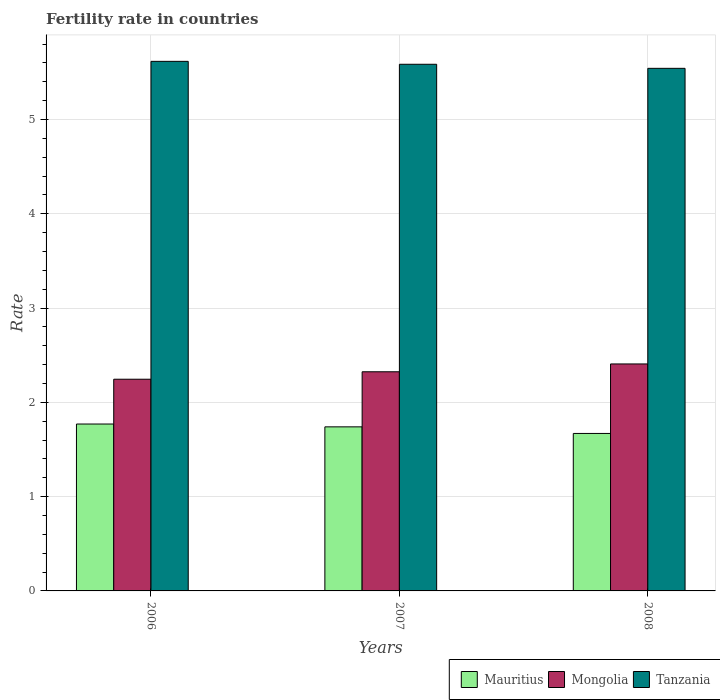Are the number of bars per tick equal to the number of legend labels?
Keep it short and to the point. Yes. Are the number of bars on each tick of the X-axis equal?
Offer a terse response. Yes. How many bars are there on the 2nd tick from the right?
Offer a very short reply. 3. What is the fertility rate in Mauritius in 2008?
Give a very brief answer. 1.67. Across all years, what is the maximum fertility rate in Tanzania?
Ensure brevity in your answer.  5.62. Across all years, what is the minimum fertility rate in Tanzania?
Ensure brevity in your answer.  5.54. In which year was the fertility rate in Tanzania maximum?
Ensure brevity in your answer.  2006. What is the total fertility rate in Tanzania in the graph?
Give a very brief answer. 16.74. What is the difference between the fertility rate in Mongolia in 2007 and that in 2008?
Your answer should be compact. -0.08. What is the difference between the fertility rate in Mauritius in 2008 and the fertility rate in Mongolia in 2006?
Your response must be concise. -0.58. What is the average fertility rate in Mauritius per year?
Ensure brevity in your answer.  1.73. In the year 2008, what is the difference between the fertility rate in Mauritius and fertility rate in Tanzania?
Offer a very short reply. -3.87. What is the ratio of the fertility rate in Tanzania in 2006 to that in 2007?
Provide a short and direct response. 1.01. Is the fertility rate in Mongolia in 2006 less than that in 2007?
Your answer should be very brief. Yes. Is the difference between the fertility rate in Mauritius in 2007 and 2008 greater than the difference between the fertility rate in Tanzania in 2007 and 2008?
Ensure brevity in your answer.  Yes. What is the difference between the highest and the second highest fertility rate in Tanzania?
Offer a terse response. 0.03. What is the difference between the highest and the lowest fertility rate in Tanzania?
Make the answer very short. 0.07. Is the sum of the fertility rate in Tanzania in 2006 and 2008 greater than the maximum fertility rate in Mauritius across all years?
Offer a terse response. Yes. What does the 3rd bar from the left in 2008 represents?
Offer a very short reply. Tanzania. What does the 2nd bar from the right in 2006 represents?
Keep it short and to the point. Mongolia. How many bars are there?
Keep it short and to the point. 9. Are the values on the major ticks of Y-axis written in scientific E-notation?
Keep it short and to the point. No. Does the graph contain grids?
Your answer should be very brief. Yes. Where does the legend appear in the graph?
Your answer should be compact. Bottom right. How many legend labels are there?
Give a very brief answer. 3. How are the legend labels stacked?
Give a very brief answer. Horizontal. What is the title of the graph?
Provide a short and direct response. Fertility rate in countries. Does "St. Kitts and Nevis" appear as one of the legend labels in the graph?
Offer a terse response. No. What is the label or title of the X-axis?
Provide a short and direct response. Years. What is the label or title of the Y-axis?
Provide a succinct answer. Rate. What is the Rate in Mauritius in 2006?
Ensure brevity in your answer.  1.77. What is the Rate of Mongolia in 2006?
Provide a short and direct response. 2.25. What is the Rate of Tanzania in 2006?
Provide a succinct answer. 5.62. What is the Rate in Mauritius in 2007?
Keep it short and to the point. 1.74. What is the Rate in Mongolia in 2007?
Keep it short and to the point. 2.32. What is the Rate of Tanzania in 2007?
Provide a succinct answer. 5.58. What is the Rate of Mauritius in 2008?
Your answer should be compact. 1.67. What is the Rate of Mongolia in 2008?
Offer a terse response. 2.41. What is the Rate in Tanzania in 2008?
Ensure brevity in your answer.  5.54. Across all years, what is the maximum Rate of Mauritius?
Offer a very short reply. 1.77. Across all years, what is the maximum Rate in Mongolia?
Make the answer very short. 2.41. Across all years, what is the maximum Rate in Tanzania?
Your answer should be very brief. 5.62. Across all years, what is the minimum Rate of Mauritius?
Provide a short and direct response. 1.67. Across all years, what is the minimum Rate of Mongolia?
Ensure brevity in your answer.  2.25. Across all years, what is the minimum Rate of Tanzania?
Ensure brevity in your answer.  5.54. What is the total Rate in Mauritius in the graph?
Make the answer very short. 5.18. What is the total Rate in Mongolia in the graph?
Give a very brief answer. 6.98. What is the total Rate in Tanzania in the graph?
Your answer should be very brief. 16.74. What is the difference between the Rate of Mauritius in 2006 and that in 2007?
Provide a succinct answer. 0.03. What is the difference between the Rate of Mongolia in 2006 and that in 2007?
Keep it short and to the point. -0.08. What is the difference between the Rate of Tanzania in 2006 and that in 2007?
Make the answer very short. 0.03. What is the difference between the Rate in Mauritius in 2006 and that in 2008?
Offer a very short reply. 0.1. What is the difference between the Rate in Mongolia in 2006 and that in 2008?
Your response must be concise. -0.16. What is the difference between the Rate of Tanzania in 2006 and that in 2008?
Provide a short and direct response. 0.07. What is the difference between the Rate in Mauritius in 2007 and that in 2008?
Your answer should be compact. 0.07. What is the difference between the Rate in Mongolia in 2007 and that in 2008?
Make the answer very short. -0.08. What is the difference between the Rate in Tanzania in 2007 and that in 2008?
Give a very brief answer. 0.04. What is the difference between the Rate of Mauritius in 2006 and the Rate of Mongolia in 2007?
Provide a short and direct response. -0.55. What is the difference between the Rate in Mauritius in 2006 and the Rate in Tanzania in 2007?
Offer a very short reply. -3.81. What is the difference between the Rate of Mongolia in 2006 and the Rate of Tanzania in 2007?
Your answer should be compact. -3.34. What is the difference between the Rate in Mauritius in 2006 and the Rate in Mongolia in 2008?
Provide a short and direct response. -0.64. What is the difference between the Rate of Mauritius in 2006 and the Rate of Tanzania in 2008?
Your answer should be very brief. -3.77. What is the difference between the Rate of Mongolia in 2006 and the Rate of Tanzania in 2008?
Give a very brief answer. -3.3. What is the difference between the Rate in Mauritius in 2007 and the Rate in Mongolia in 2008?
Ensure brevity in your answer.  -0.67. What is the difference between the Rate in Mauritius in 2007 and the Rate in Tanzania in 2008?
Your response must be concise. -3.8. What is the difference between the Rate of Mongolia in 2007 and the Rate of Tanzania in 2008?
Make the answer very short. -3.22. What is the average Rate of Mauritius per year?
Ensure brevity in your answer.  1.73. What is the average Rate of Mongolia per year?
Make the answer very short. 2.33. What is the average Rate of Tanzania per year?
Your answer should be compact. 5.58. In the year 2006, what is the difference between the Rate of Mauritius and Rate of Mongolia?
Provide a short and direct response. -0.47. In the year 2006, what is the difference between the Rate of Mauritius and Rate of Tanzania?
Your answer should be compact. -3.85. In the year 2006, what is the difference between the Rate in Mongolia and Rate in Tanzania?
Your answer should be compact. -3.37. In the year 2007, what is the difference between the Rate of Mauritius and Rate of Mongolia?
Ensure brevity in your answer.  -0.58. In the year 2007, what is the difference between the Rate in Mauritius and Rate in Tanzania?
Make the answer very short. -3.85. In the year 2007, what is the difference between the Rate of Mongolia and Rate of Tanzania?
Your answer should be compact. -3.26. In the year 2008, what is the difference between the Rate of Mauritius and Rate of Mongolia?
Your answer should be very brief. -0.74. In the year 2008, what is the difference between the Rate of Mauritius and Rate of Tanzania?
Your response must be concise. -3.87. In the year 2008, what is the difference between the Rate in Mongolia and Rate in Tanzania?
Keep it short and to the point. -3.13. What is the ratio of the Rate of Mauritius in 2006 to that in 2007?
Provide a short and direct response. 1.02. What is the ratio of the Rate in Mongolia in 2006 to that in 2007?
Provide a short and direct response. 0.97. What is the ratio of the Rate in Tanzania in 2006 to that in 2007?
Your response must be concise. 1.01. What is the ratio of the Rate in Mauritius in 2006 to that in 2008?
Offer a very short reply. 1.06. What is the ratio of the Rate of Mongolia in 2006 to that in 2008?
Provide a short and direct response. 0.93. What is the ratio of the Rate in Tanzania in 2006 to that in 2008?
Offer a terse response. 1.01. What is the ratio of the Rate of Mauritius in 2007 to that in 2008?
Give a very brief answer. 1.04. What is the ratio of the Rate in Mongolia in 2007 to that in 2008?
Your answer should be very brief. 0.97. What is the difference between the highest and the second highest Rate of Mongolia?
Your answer should be compact. 0.08. What is the difference between the highest and the second highest Rate in Tanzania?
Keep it short and to the point. 0.03. What is the difference between the highest and the lowest Rate in Mauritius?
Your answer should be very brief. 0.1. What is the difference between the highest and the lowest Rate in Mongolia?
Give a very brief answer. 0.16. What is the difference between the highest and the lowest Rate of Tanzania?
Your answer should be very brief. 0.07. 